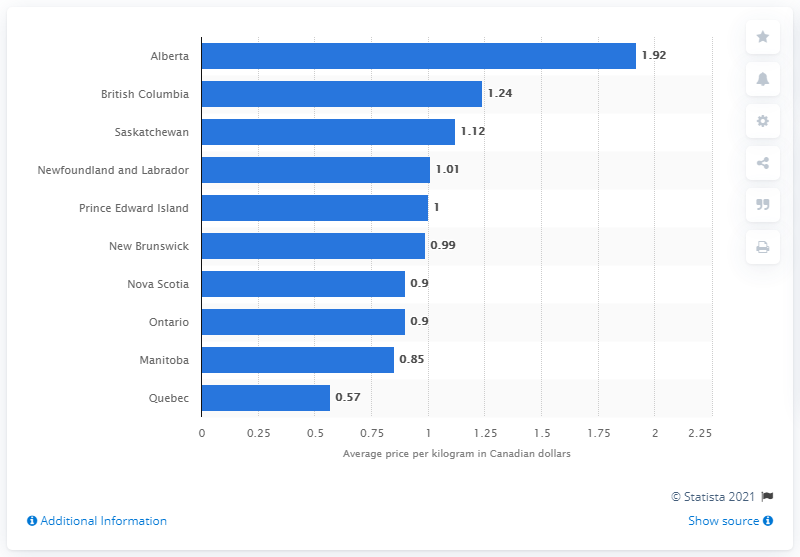Point out several critical features in this image. In 2018, the average Canadian dollar per kilogram for wool producers in Alberta was 1.92. In 2018, the average Canadian dollar per kilogram for wool producers in Quebec was 0.57. 